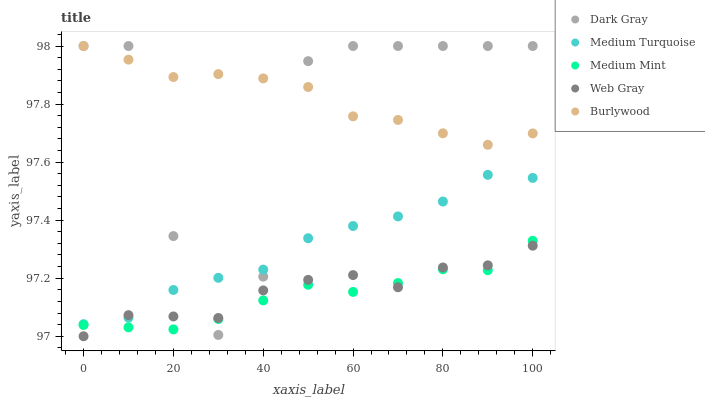Does Medium Mint have the minimum area under the curve?
Answer yes or no. Yes. Does Burlywood have the maximum area under the curve?
Answer yes or no. Yes. Does Web Gray have the minimum area under the curve?
Answer yes or no. No. Does Web Gray have the maximum area under the curve?
Answer yes or no. No. Is Medium Mint the smoothest?
Answer yes or no. Yes. Is Dark Gray the roughest?
Answer yes or no. Yes. Is Web Gray the smoothest?
Answer yes or no. No. Is Web Gray the roughest?
Answer yes or no. No. Does Web Gray have the lowest value?
Answer yes or no. Yes. Does Medium Mint have the lowest value?
Answer yes or no. No. Does Burlywood have the highest value?
Answer yes or no. Yes. Does Medium Mint have the highest value?
Answer yes or no. No. Is Medium Mint less than Medium Turquoise?
Answer yes or no. Yes. Is Medium Turquoise greater than Medium Mint?
Answer yes or no. Yes. Does Medium Mint intersect Dark Gray?
Answer yes or no. Yes. Is Medium Mint less than Dark Gray?
Answer yes or no. No. Is Medium Mint greater than Dark Gray?
Answer yes or no. No. Does Medium Mint intersect Medium Turquoise?
Answer yes or no. No. 